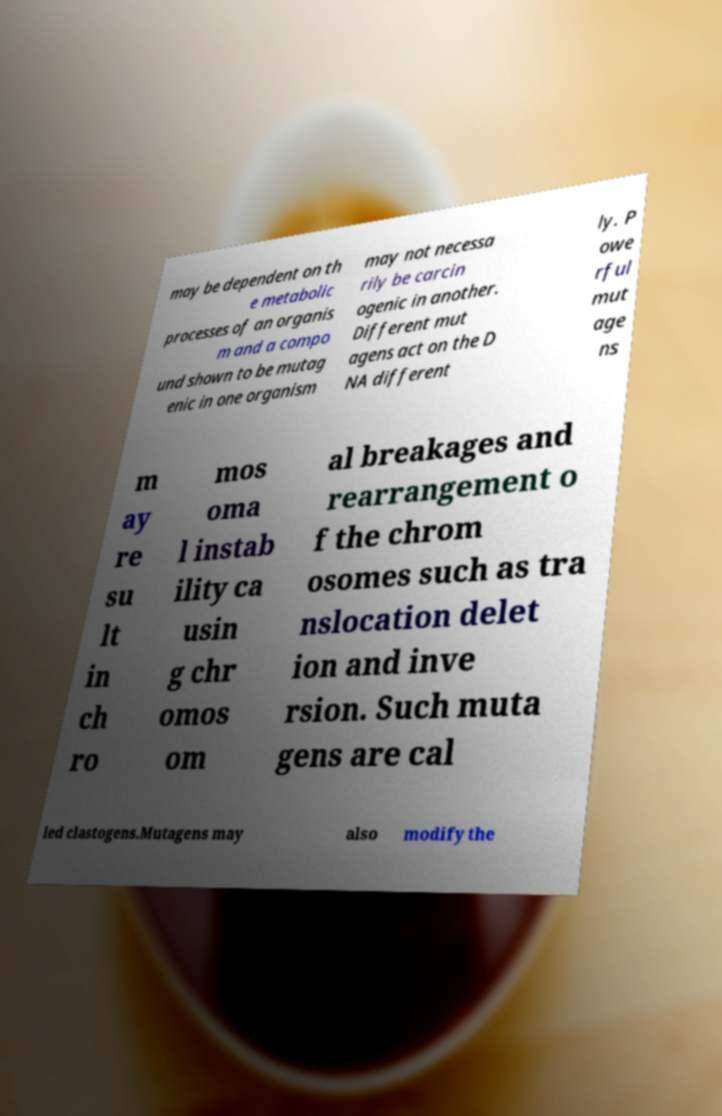Please read and relay the text visible in this image. What does it say? may be dependent on th e metabolic processes of an organis m and a compo und shown to be mutag enic in one organism may not necessa rily be carcin ogenic in another. Different mut agens act on the D NA different ly. P owe rful mut age ns m ay re su lt in ch ro mos oma l instab ility ca usin g chr omos om al breakages and rearrangement o f the chrom osomes such as tra nslocation delet ion and inve rsion. Such muta gens are cal led clastogens.Mutagens may also modify the 